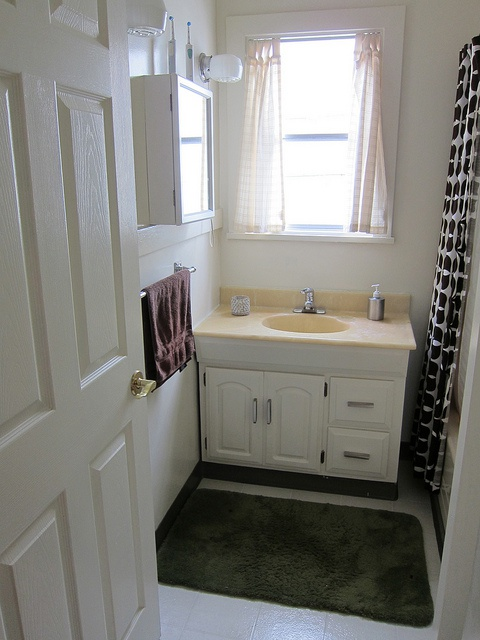Describe the objects in this image and their specific colors. I can see sink in gray, tan, darkgray, and lightgray tones, toothbrush in gray, darkgray, and lightgray tones, and toothbrush in gray and darkgray tones in this image. 